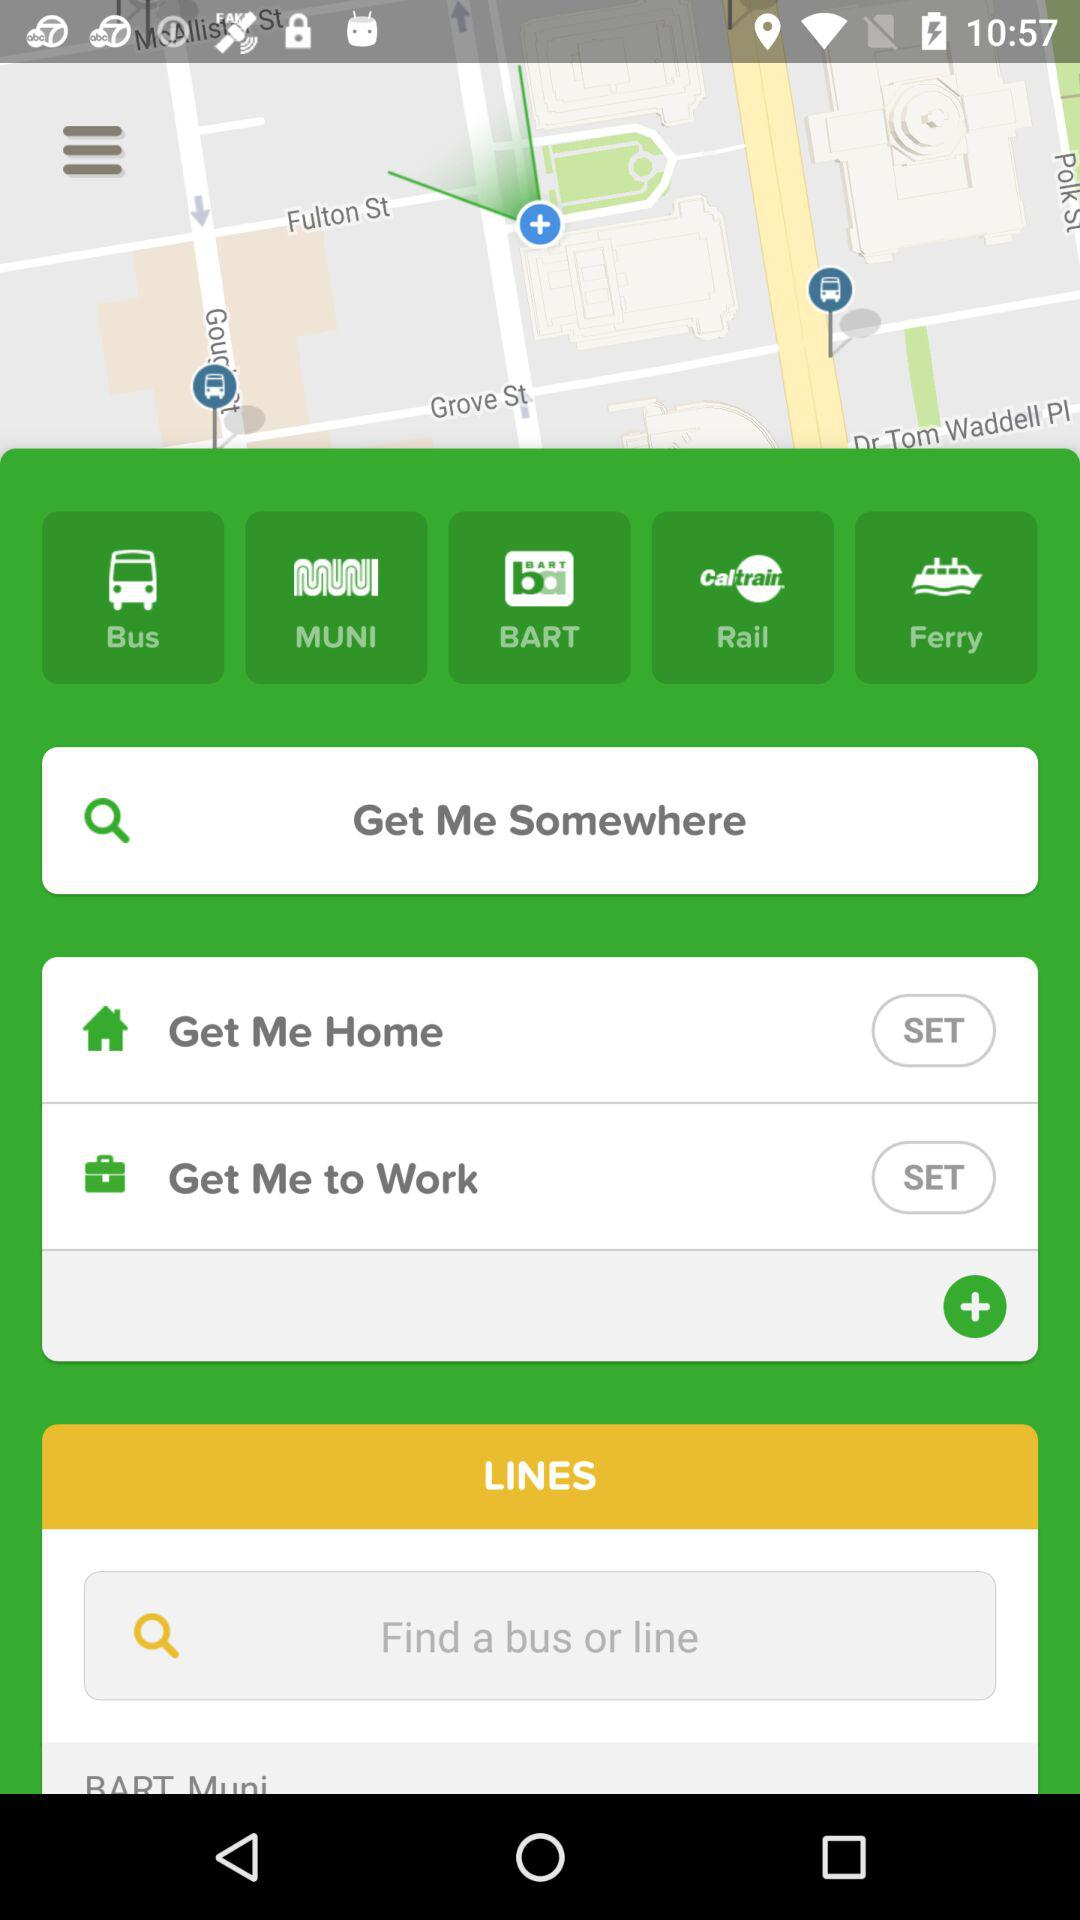How many lines of public transportation are available?
Answer the question using a single word or phrase. 5 